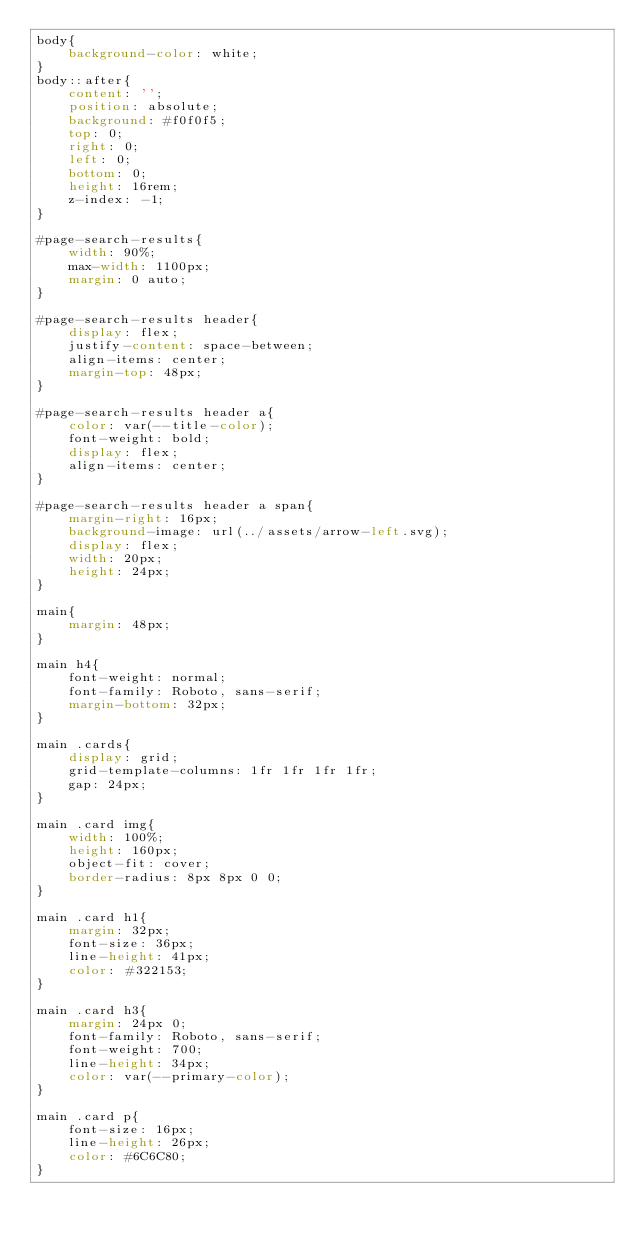Convert code to text. <code><loc_0><loc_0><loc_500><loc_500><_CSS_>body{
    background-color: white;
}
body::after{
    content: '';
    position: absolute;
    background: #f0f0f5;
    top: 0;
    right: 0;
    left: 0;
    bottom: 0;
    height: 16rem;
    z-index: -1;
}

#page-search-results{
    width: 90%;
    max-width: 1100px;
    margin: 0 auto;
}

#page-search-results header{
    display: flex;
    justify-content: space-between;
    align-items: center;
    margin-top: 48px;
}

#page-search-results header a{
    color: var(--title-color);
    font-weight: bold;
    display: flex;
    align-items: center;
}

#page-search-results header a span{
    margin-right: 16px;
    background-image: url(../assets/arrow-left.svg);
    display: flex;
    width: 20px;
    height: 24px;
}

main{
    margin: 48px;
}

main h4{
    font-weight: normal;
    font-family: Roboto, sans-serif;
    margin-bottom: 32px;
}

main .cards{
    display: grid;
    grid-template-columns: 1fr 1fr 1fr 1fr;
    gap: 24px;
}

main .card img{
    width: 100%;
    height: 160px;
    object-fit: cover;
    border-radius: 8px 8px 0 0;
}

main .card h1{
    margin: 32px;
    font-size: 36px;
    line-height: 41px;
    color: #322153;
}

main .card h3{
    margin: 24px 0;
    font-family: Roboto, sans-serif;
    font-weight: 700;
    line-height: 34px;
    color: var(--primary-color);
}

main .card p{
    font-size: 16px;
    line-height: 26px;
    color: #6C6C80;
}



</code> 